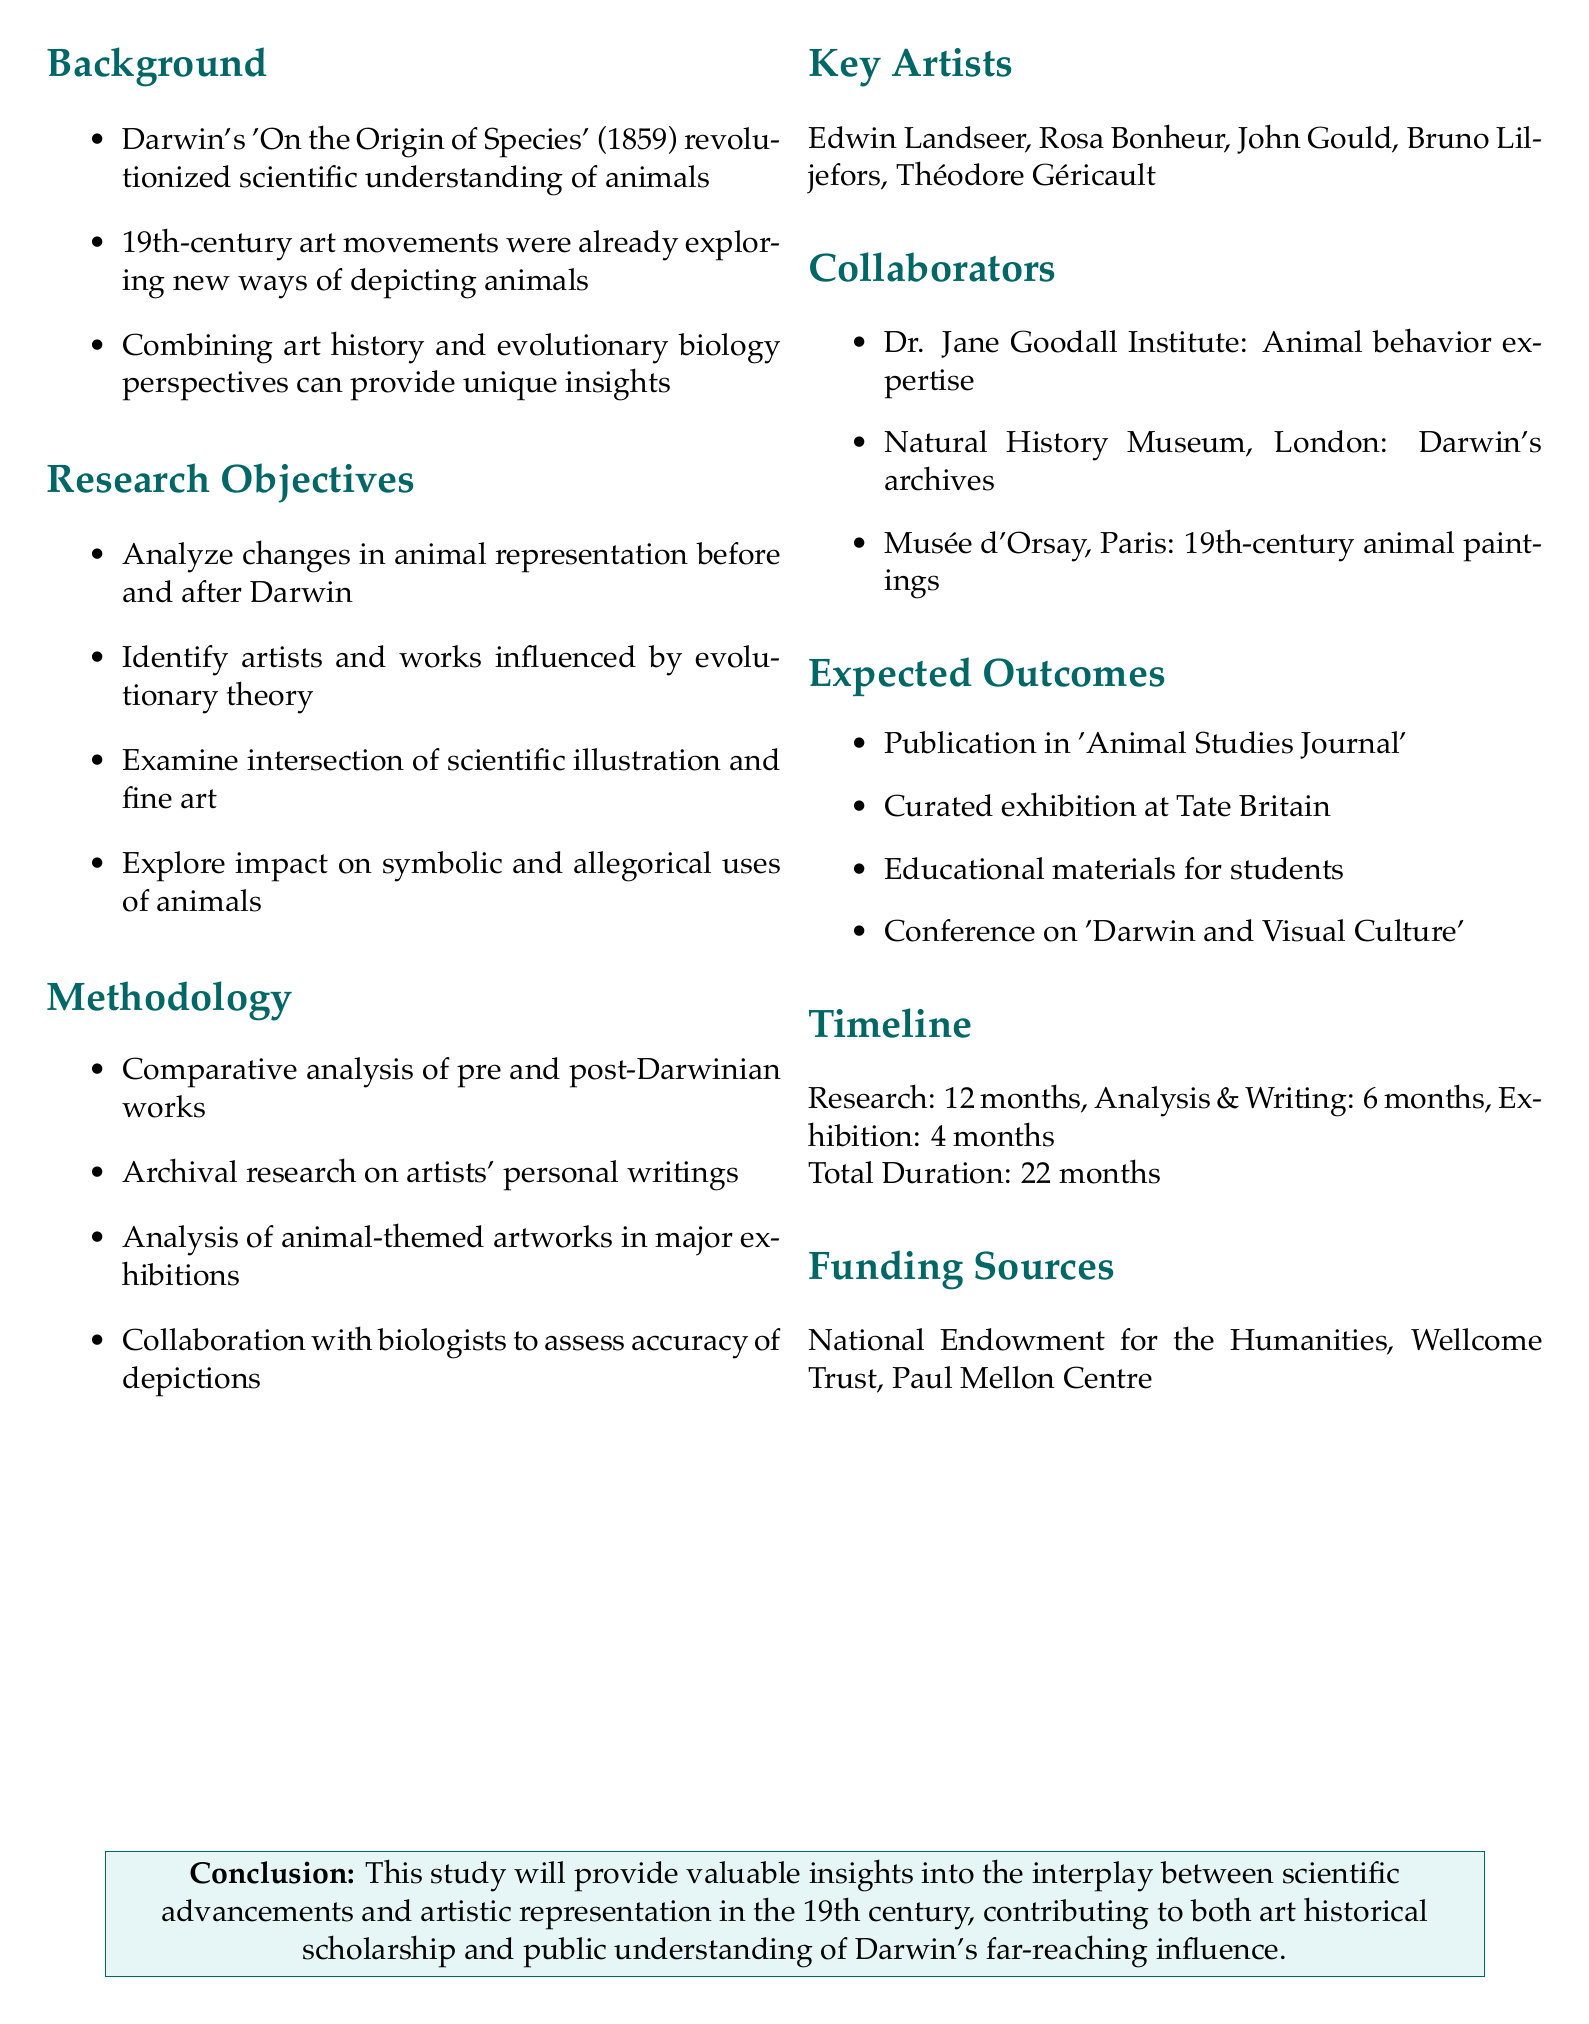What is the memo's title? The title summarizes the main focus of the collaborative study proposed in the document.
Answer: Proposal for Collaborative Study: Darwin's Impact on Animal Depictions in 19th-Century Art What are the key artists to study? The document lists a selection of artists whose works impacted animal depictions after Darwin's theories.
Answer: Edwin Landseer, Rosa Bonheur, John Gould, Bruno Liljefors, Théodore Géricault How long is the research phase? The document specifies the duration allocated for the research phase within the overall project timeline.
Answer: 12 months What is one expected outcome of the study? The document outlines specific outcomes anticipated from the collaborative study, indicating successful dissemination of findings.
Answer: Publication in 'Animal Studies Journal' Which organization is mentioned for collaboration regarding animal behavior? The document details potential collaborators who can bring specific expertise to the study, including animal behavior.
Answer: Dr. Jane Goodall Institute What is the total duration of the project? The timeline section adds all phases together to provide the total duration of the entire study.
Answer: 22 months What type of analysis is proposed as methodology? The document outlines different methods to be used in the study, emphasizing the comparative approach.
Answer: Comparative analysis What does the conclusion state about the study's contributions? The conclusion summarizes the significance of the study in a broad context regarding art and science interplay.
Answer: Valuable insights into the interplay between scientific advancements and artistic representation 